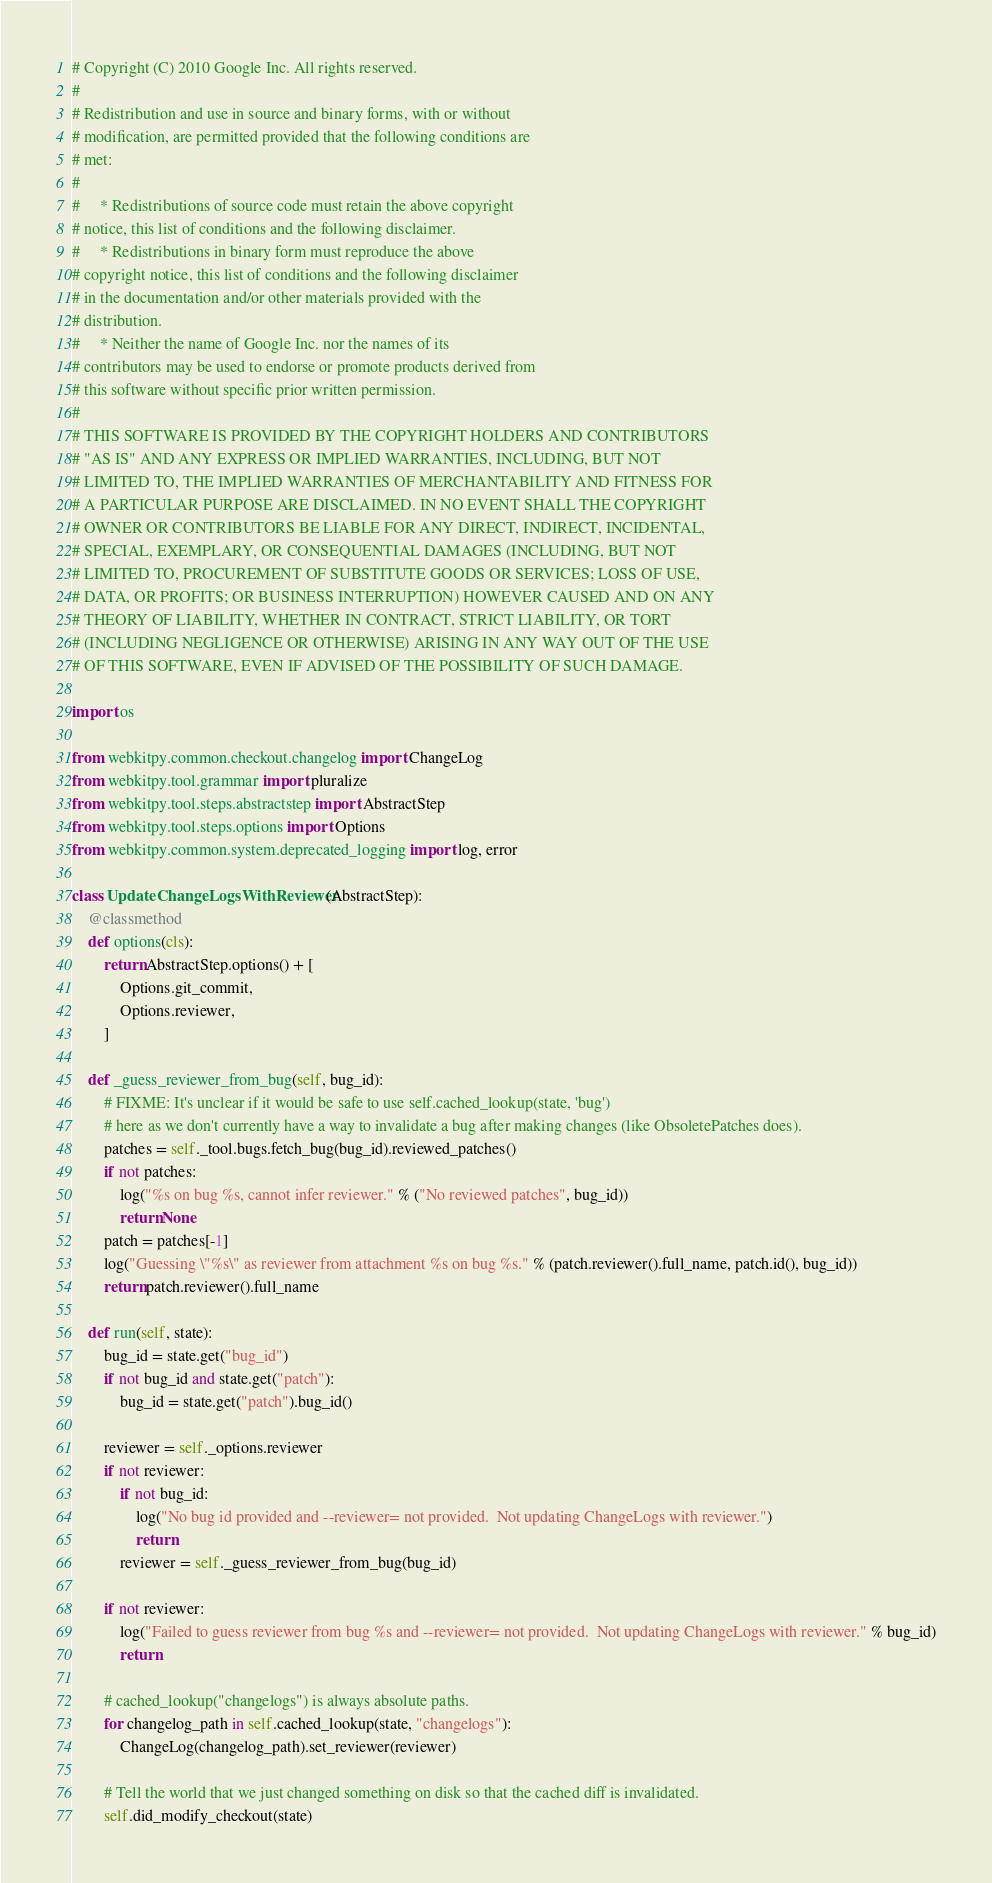<code> <loc_0><loc_0><loc_500><loc_500><_Python_># Copyright (C) 2010 Google Inc. All rights reserved.
# 
# Redistribution and use in source and binary forms, with or without
# modification, are permitted provided that the following conditions are
# met:
# 
#     * Redistributions of source code must retain the above copyright
# notice, this list of conditions and the following disclaimer.
#     * Redistributions in binary form must reproduce the above
# copyright notice, this list of conditions and the following disclaimer
# in the documentation and/or other materials provided with the
# distribution.
#     * Neither the name of Google Inc. nor the names of its
# contributors may be used to endorse or promote products derived from
# this software without specific prior written permission.
# 
# THIS SOFTWARE IS PROVIDED BY THE COPYRIGHT HOLDERS AND CONTRIBUTORS
# "AS IS" AND ANY EXPRESS OR IMPLIED WARRANTIES, INCLUDING, BUT NOT
# LIMITED TO, THE IMPLIED WARRANTIES OF MERCHANTABILITY AND FITNESS FOR
# A PARTICULAR PURPOSE ARE DISCLAIMED. IN NO EVENT SHALL THE COPYRIGHT
# OWNER OR CONTRIBUTORS BE LIABLE FOR ANY DIRECT, INDIRECT, INCIDENTAL,
# SPECIAL, EXEMPLARY, OR CONSEQUENTIAL DAMAGES (INCLUDING, BUT NOT
# LIMITED TO, PROCUREMENT OF SUBSTITUTE GOODS OR SERVICES; LOSS OF USE,
# DATA, OR PROFITS; OR BUSINESS INTERRUPTION) HOWEVER CAUSED AND ON ANY
# THEORY OF LIABILITY, WHETHER IN CONTRACT, STRICT LIABILITY, OR TORT
# (INCLUDING NEGLIGENCE OR OTHERWISE) ARISING IN ANY WAY OUT OF THE USE
# OF THIS SOFTWARE, EVEN IF ADVISED OF THE POSSIBILITY OF SUCH DAMAGE.

import os

from webkitpy.common.checkout.changelog import ChangeLog
from webkitpy.tool.grammar import pluralize
from webkitpy.tool.steps.abstractstep import AbstractStep
from webkitpy.tool.steps.options import Options
from webkitpy.common.system.deprecated_logging import log, error

class UpdateChangeLogsWithReviewer(AbstractStep):
    @classmethod
    def options(cls):
        return AbstractStep.options() + [
            Options.git_commit,
            Options.reviewer,
        ]

    def _guess_reviewer_from_bug(self, bug_id):
        # FIXME: It's unclear if it would be safe to use self.cached_lookup(state, 'bug')
        # here as we don't currently have a way to invalidate a bug after making changes (like ObsoletePatches does).
        patches = self._tool.bugs.fetch_bug(bug_id).reviewed_patches()
        if not patches:
            log("%s on bug %s, cannot infer reviewer." % ("No reviewed patches", bug_id))
            return None
        patch = patches[-1]
        log("Guessing \"%s\" as reviewer from attachment %s on bug %s." % (patch.reviewer().full_name, patch.id(), bug_id))
        return patch.reviewer().full_name

    def run(self, state):
        bug_id = state.get("bug_id")
        if not bug_id and state.get("patch"):
            bug_id = state.get("patch").bug_id()

        reviewer = self._options.reviewer
        if not reviewer:
            if not bug_id:
                log("No bug id provided and --reviewer= not provided.  Not updating ChangeLogs with reviewer.")
                return
            reviewer = self._guess_reviewer_from_bug(bug_id)

        if not reviewer:
            log("Failed to guess reviewer from bug %s and --reviewer= not provided.  Not updating ChangeLogs with reviewer." % bug_id)
            return

        # cached_lookup("changelogs") is always absolute paths.
        for changelog_path in self.cached_lookup(state, "changelogs"):
            ChangeLog(changelog_path).set_reviewer(reviewer)

        # Tell the world that we just changed something on disk so that the cached diff is invalidated.
        self.did_modify_checkout(state)
</code> 